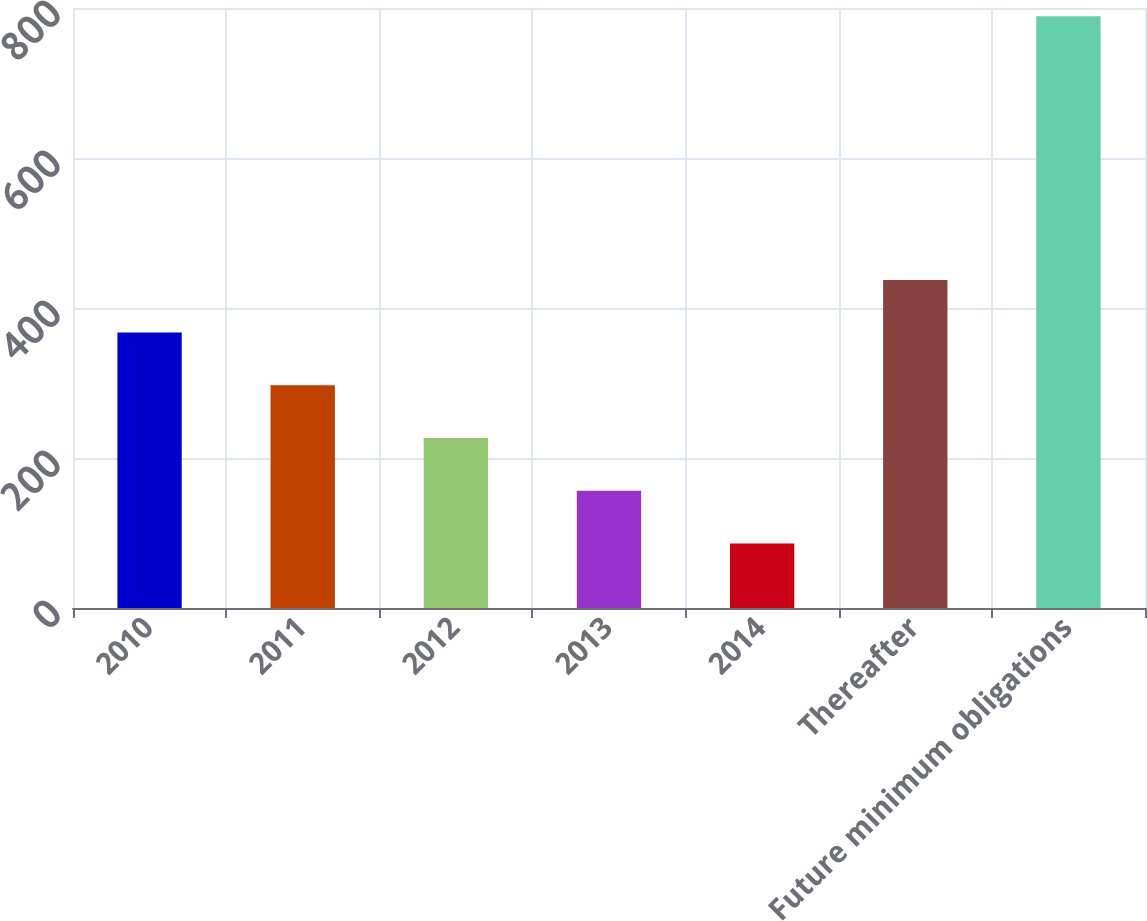Convert chart. <chart><loc_0><loc_0><loc_500><loc_500><bar_chart><fcel>2010<fcel>2011<fcel>2012<fcel>2013<fcel>2014<fcel>Thereafter<fcel>Future minimum obligations<nl><fcel>367.2<fcel>296.9<fcel>226.6<fcel>156.3<fcel>86<fcel>437.5<fcel>789<nl></chart> 